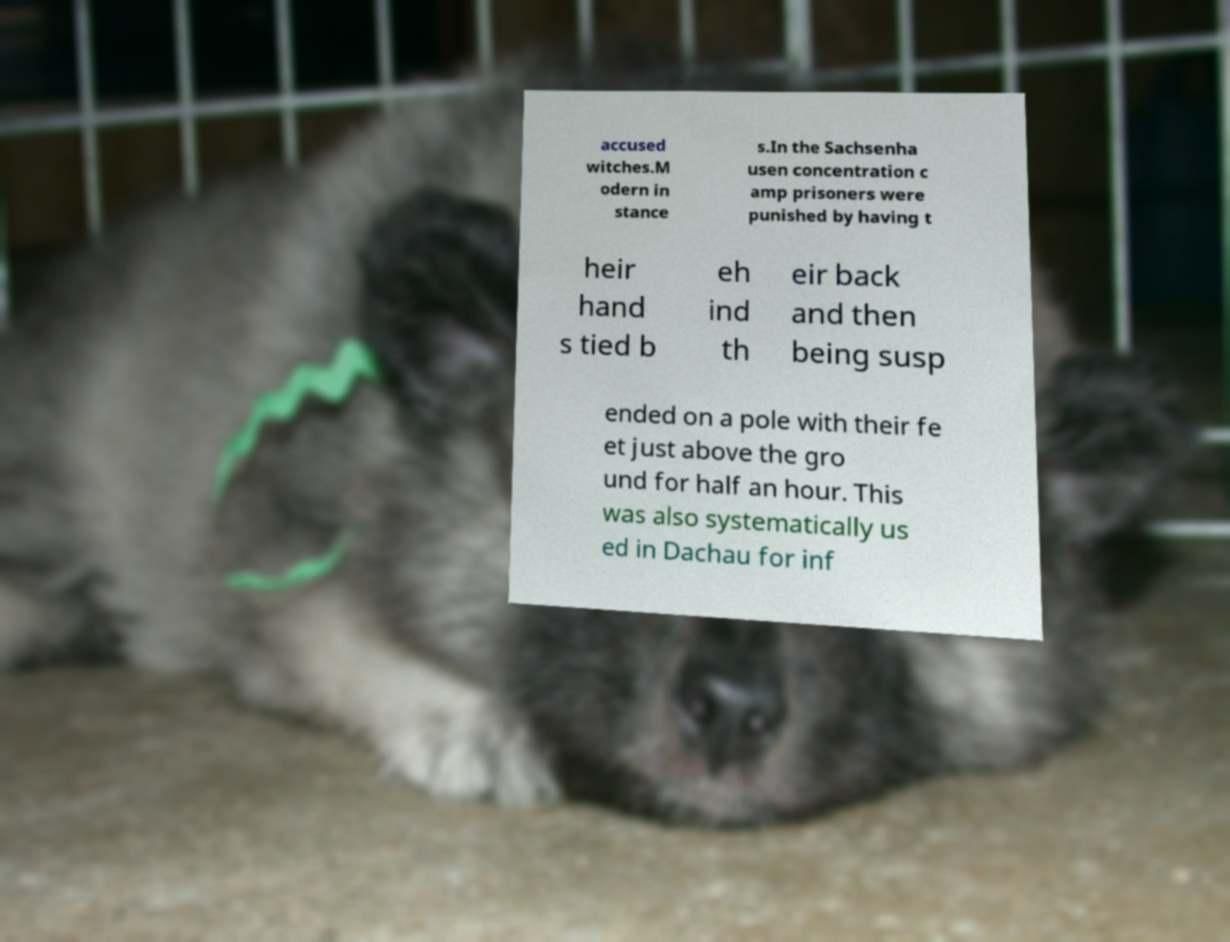Please read and relay the text visible in this image. What does it say? accused witches.M odern in stance s.In the Sachsenha usen concentration c amp prisoners were punished by having t heir hand s tied b eh ind th eir back and then being susp ended on a pole with their fe et just above the gro und for half an hour. This was also systematically us ed in Dachau for inf 